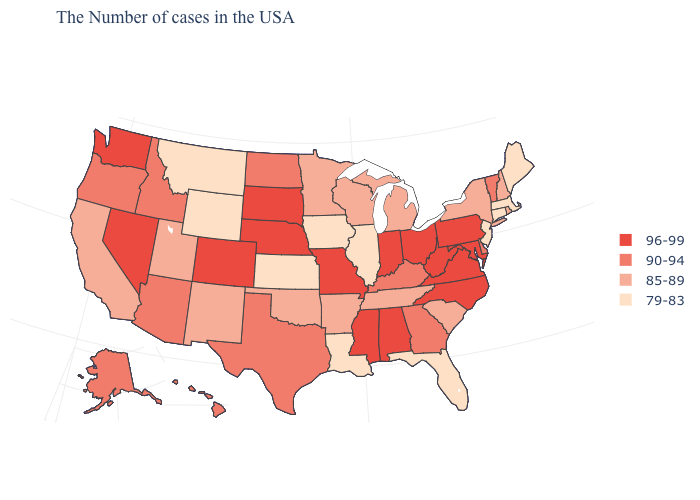Name the states that have a value in the range 85-89?
Short answer required. Rhode Island, New Hampshire, New York, South Carolina, Michigan, Tennessee, Wisconsin, Arkansas, Minnesota, Oklahoma, New Mexico, Utah, California. How many symbols are there in the legend?
Concise answer only. 4. Does Nevada have the same value as North Carolina?
Write a very short answer. Yes. Does North Carolina have the highest value in the South?
Give a very brief answer. Yes. Among the states that border Kansas , does Oklahoma have the lowest value?
Keep it brief. Yes. Does the map have missing data?
Give a very brief answer. No. What is the value of New Jersey?
Give a very brief answer. 79-83. Does Michigan have a higher value than Washington?
Concise answer only. No. Among the states that border Mississippi , does Louisiana have the lowest value?
Be succinct. Yes. Does Maine have the lowest value in the Northeast?
Keep it brief. Yes. What is the lowest value in the MidWest?
Be succinct. 79-83. Which states have the highest value in the USA?
Be succinct. Maryland, Pennsylvania, Virginia, North Carolina, West Virginia, Ohio, Indiana, Alabama, Mississippi, Missouri, Nebraska, South Dakota, Colorado, Nevada, Washington. Does the first symbol in the legend represent the smallest category?
Short answer required. No. What is the lowest value in states that border Massachusetts?
Concise answer only. 79-83. Name the states that have a value in the range 79-83?
Give a very brief answer. Maine, Massachusetts, Connecticut, New Jersey, Florida, Illinois, Louisiana, Iowa, Kansas, Wyoming, Montana. 